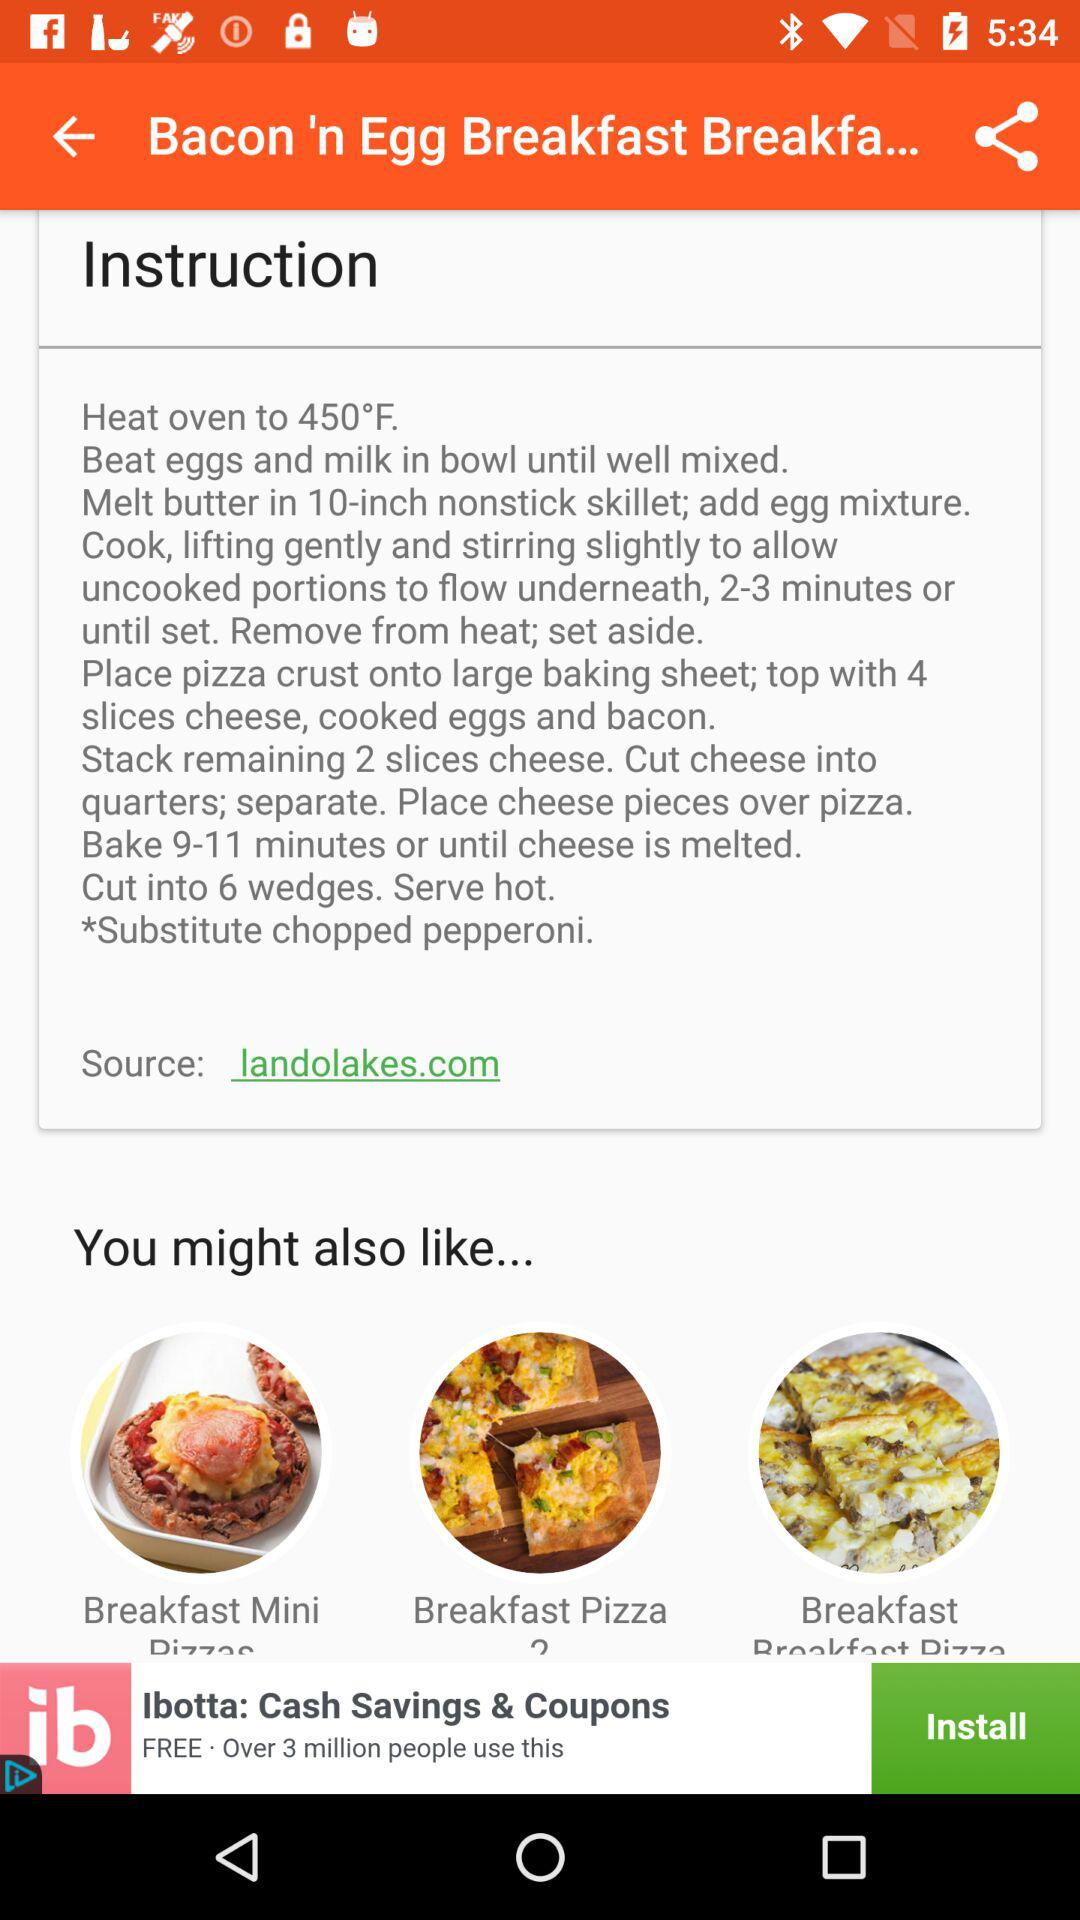What is the source? The source is landolakes.com. 